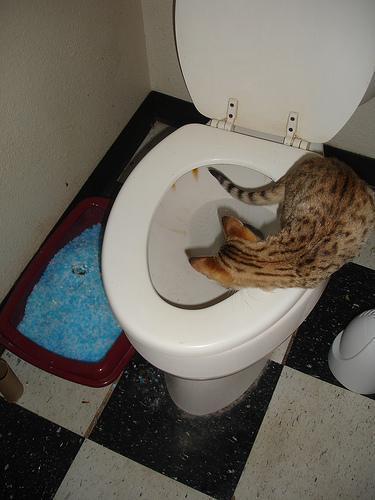How many cats are there?
Give a very brief answer. 1. How many cats are shown?
Give a very brief answer. 1. How many animals are shown?
Give a very brief answer. 1. How many toilets are there?
Give a very brief answer. 1. 